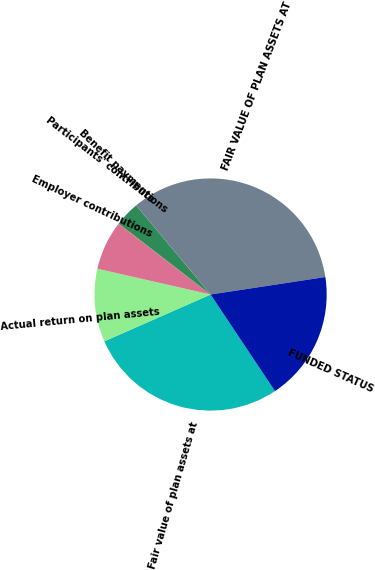Convert chart. <chart><loc_0><loc_0><loc_500><loc_500><pie_chart><fcel>Fair value of plan assets at<fcel>Actual return on plan assets<fcel>Employer contributions<fcel>Participants' contributions<fcel>Benefit payments<fcel>FAIR VALUE OF PLAN ASSETS AT<fcel>FUNDED STATUS<nl><fcel>27.76%<fcel>10.17%<fcel>6.81%<fcel>0.09%<fcel>3.45%<fcel>33.68%<fcel>18.05%<nl></chart> 